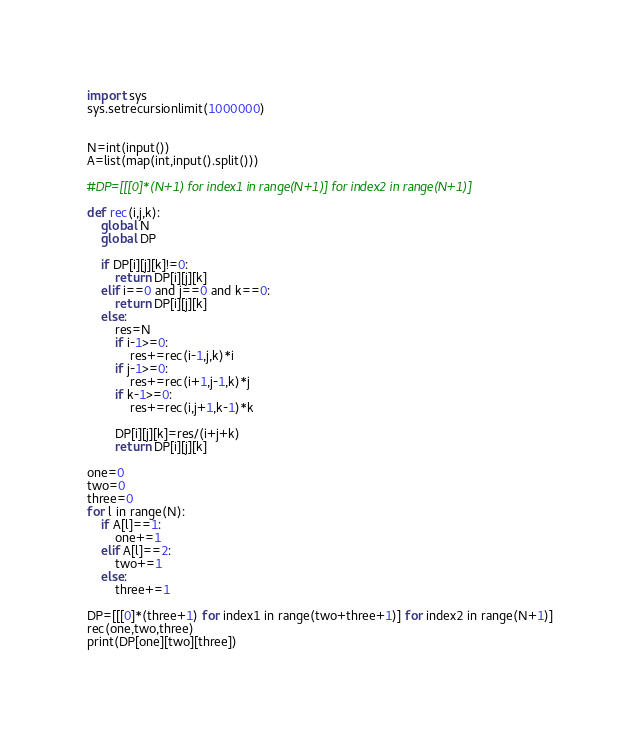Convert code to text. <code><loc_0><loc_0><loc_500><loc_500><_Python_>import sys
sys.setrecursionlimit(1000000)


N=int(input())
A=list(map(int,input().split()))

#DP=[[[0]*(N+1) for index1 in range(N+1)] for index2 in range(N+1)]

def rec(i,j,k):
    global N
    global DP

    if DP[i][j][k]!=0:
        return DP[i][j][k]
    elif i==0 and j==0 and k==0:
        return DP[i][j][k]
    else:
        res=N
        if i-1>=0:
            res+=rec(i-1,j,k)*i
        if j-1>=0:
            res+=rec(i+1,j-1,k)*j
        if k-1>=0:
            res+=rec(i,j+1,k-1)*k
        
        DP[i][j][k]=res/(i+j+k)
        return DP[i][j][k]

one=0
two=0
three=0
for l in range(N):
    if A[l]==1:
        one+=1
    elif A[l]==2:
        two+=1
    else:
        three+=1

DP=[[[0]*(three+1) for index1 in range(two+three+1)] for index2 in range(N+1)]
rec(one,two,three)
print(DP[one][two][three])

</code> 